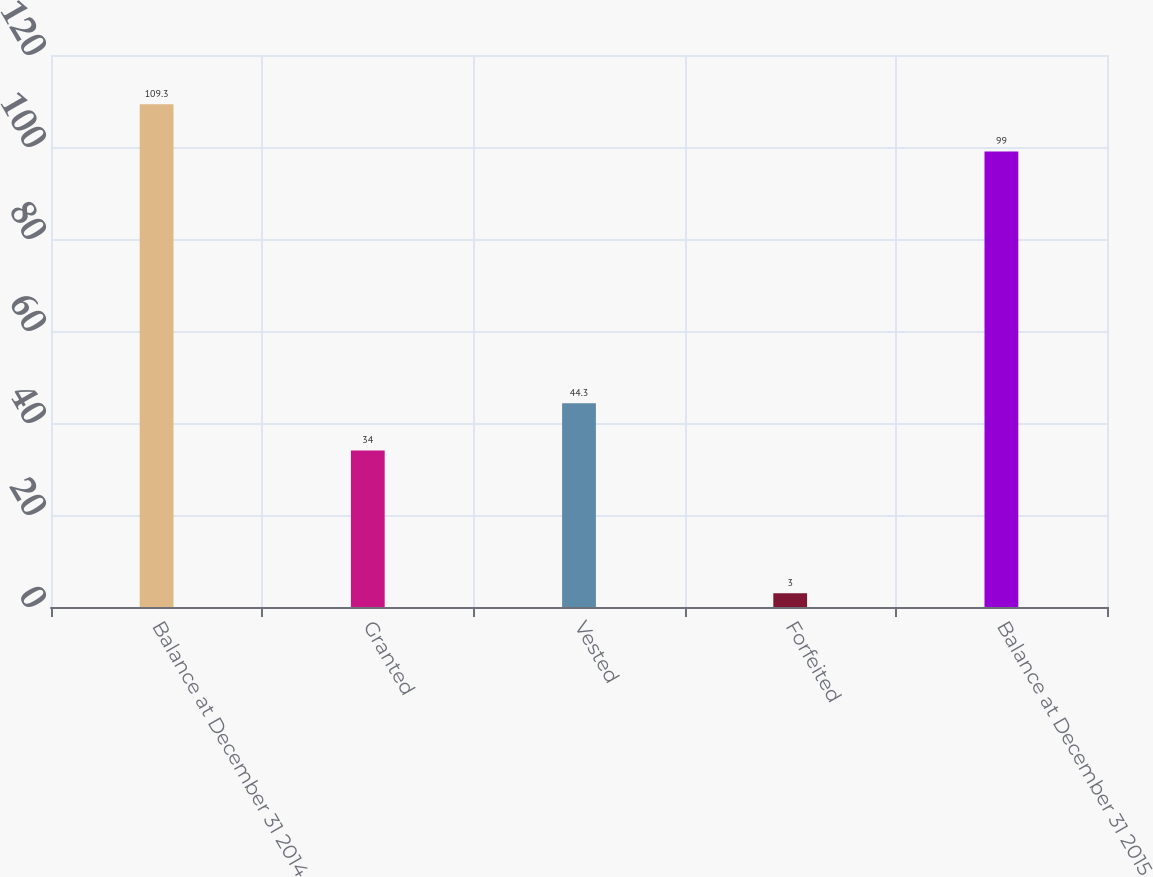<chart> <loc_0><loc_0><loc_500><loc_500><bar_chart><fcel>Balance at December 31 2014<fcel>Granted<fcel>Vested<fcel>Forfeited<fcel>Balance at December 31 2015<nl><fcel>109.3<fcel>34<fcel>44.3<fcel>3<fcel>99<nl></chart> 